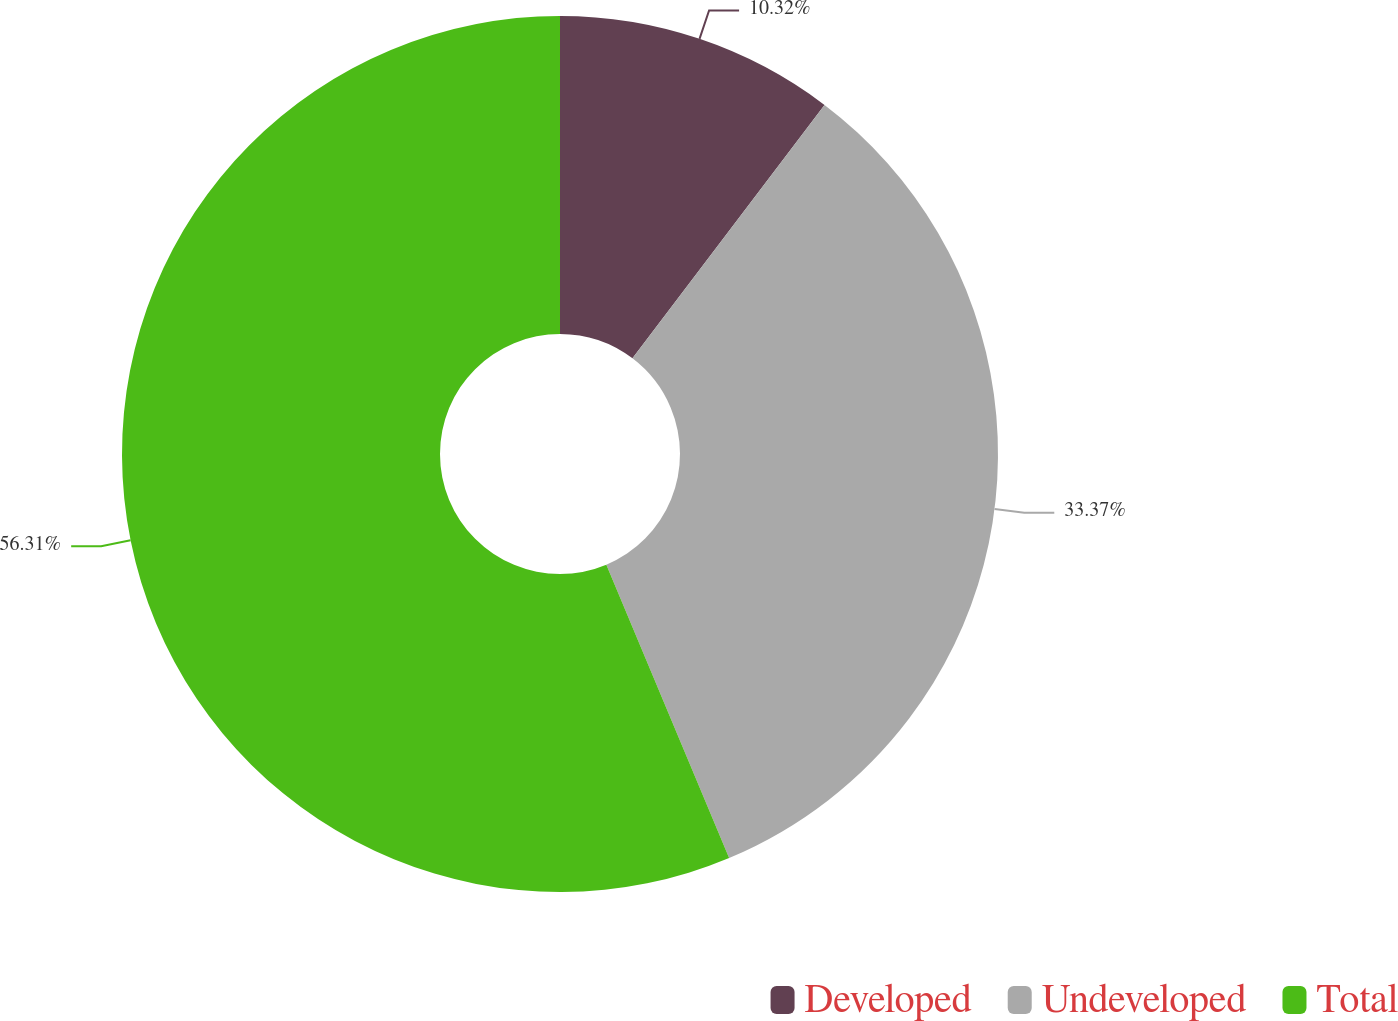Convert chart. <chart><loc_0><loc_0><loc_500><loc_500><pie_chart><fcel>Developed<fcel>Undeveloped<fcel>Total<nl><fcel>10.32%<fcel>33.37%<fcel>56.31%<nl></chart> 